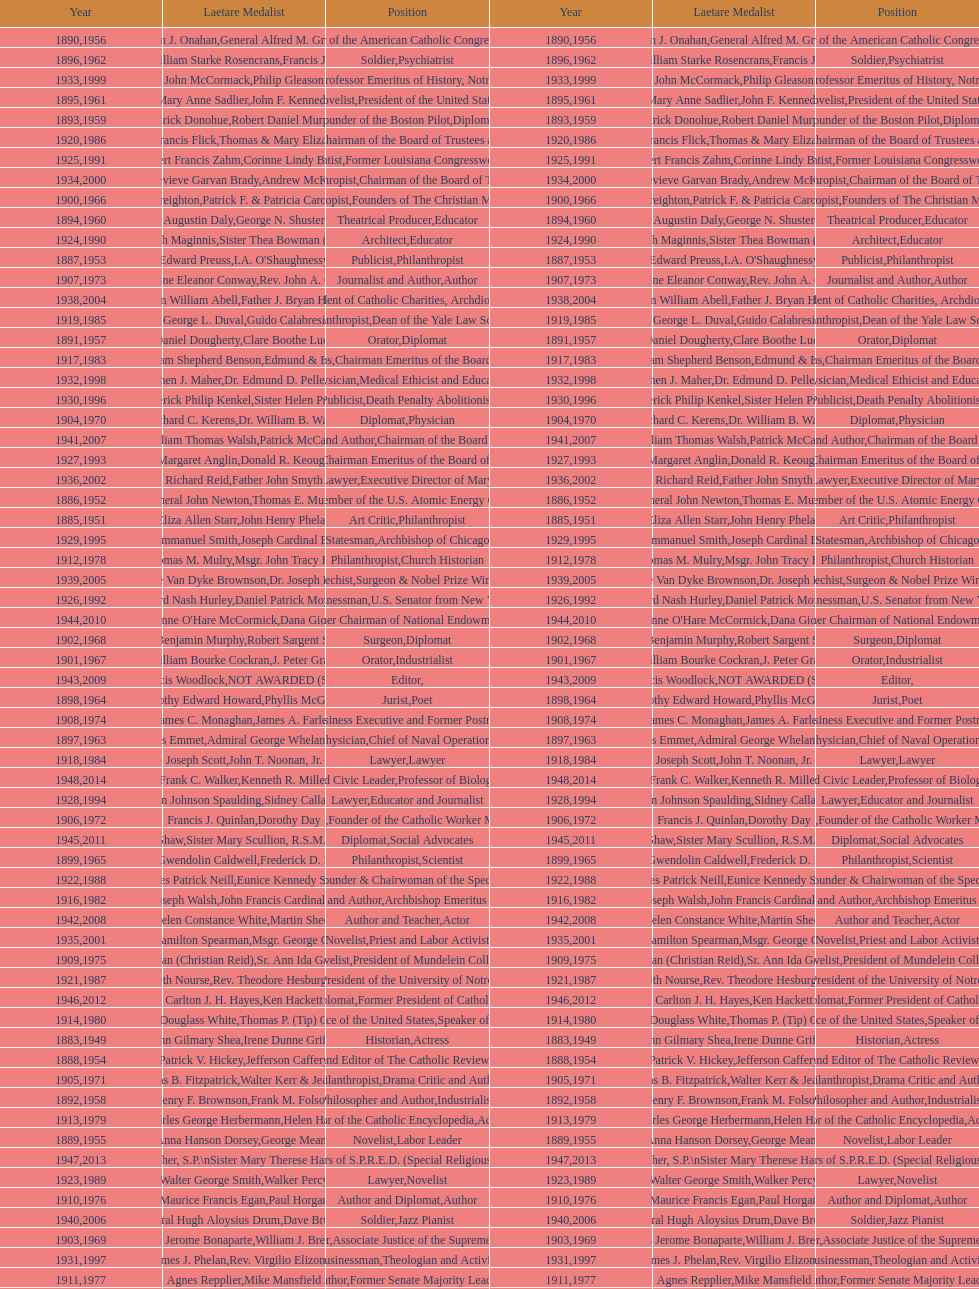What are the total number of times soldier is listed as the position on this chart? 4. Give me the full table as a dictionary. {'header': ['Year', 'Laetare Medalist', 'Position', 'Year', 'Laetare Medalist', 'Position'], 'rows': [['1890', 'William J. Onahan', 'Organizer of the American Catholic Congress', '1956', 'General Alfred M. Gruenther', 'Soldier'], ['1896', 'General William Starke Rosencrans', 'Soldier', '1962', 'Francis J. Braceland', 'Psychiatrist'], ['1933', 'John McCormack', 'Artist', '1999', 'Philip Gleason', 'Professor Emeritus of History, Notre Dame'], ['1895', 'Mary Anne Sadlier', 'Novelist', '1961', 'John F. Kennedy', 'President of the United States'], ['1893', 'Patrick Donohue', 'Founder of the Boston Pilot', '1959', 'Robert Daniel Murphy', 'Diplomat'], ['1920', 'Lawrence Francis Flick', 'Physician', '1986', 'Thomas & Mary Elizabeth Carney', 'Chairman of the Board of Trustees and his wife'], ['1925', 'Albert Francis Zahm', 'Scientist', '1991', 'Corinne Lindy Boggs', 'Former Louisiana Congresswoman'], ['1934', 'Genevieve Garvan Brady', 'Philanthropist', '2000', 'Andrew McKenna', 'Chairman of the Board of Trustees'], ['1900', 'John A. Creighton', 'Philanthropist', '1966', 'Patrick F. & Patricia Caron Crowley', 'Founders of The Christian Movement'], ['1894', 'Augustin Daly', 'Theatrical Producer', '1960', 'George N. Shuster', 'Educator'], ['1924', 'Charles Donagh Maginnis', 'Architect', '1990', 'Sister Thea Bowman (posthumously)', 'Educator'], ['1887', 'Edward Preuss', 'Publicist', '1953', "I.A. O'Shaughnessy", 'Philanthropist'], ['1907', 'Katherine Eleanor Conway', 'Journalist and Author', '1973', "Rev. John A. O'Brien", 'Author'], ['1938', 'Irvin William Abell', 'Surgeon', '2004', 'Father J. Bryan Hehir', 'President of Catholic Charities, Archdiocese of Boston'], ['1919', 'George L. Duval', 'Philanthropist', '1985', 'Guido Calabresi', 'Dean of the Yale Law School'], ['1891', 'Daniel Dougherty', 'Orator', '1957', 'Clare Boothe Luce', 'Diplomat'], ['1917', 'Admiral William Shepherd Benson', 'Chief of Naval Operations', '1983', 'Edmund & Evelyn Stephan', 'Chairman Emeritus of the Board of Trustees and his wife'], ['1932', 'Stephen J. Maher', 'Physician', '1998', 'Dr. Edmund D. Pellegrino', 'Medical Ethicist and Educator'], ['1930', 'Frederick Philip Kenkel', 'Publicist', '1996', 'Sister Helen Prejean', 'Death Penalty Abolitionist'], ['1904', 'Richard C. Kerens', 'Diplomat', '1970', 'Dr. William B. Walsh', 'Physician'], ['1941', 'William Thomas Walsh', 'Journalist and Author', '2007', 'Patrick McCartan', 'Chairman of the Board of Trustees'], ['1927', 'Margaret Anglin', 'Actress', '1993', 'Donald R. Keough', 'Chairman Emeritus of the Board of Trustees'], ['1936', 'Richard Reid', 'Journalist and Lawyer', '2002', 'Father John Smyth', 'Executive Director of Maryville Academy'], ['1886', 'General John Newton', 'Engineer', '1952', 'Thomas E. Murray', 'Member of the U.S. Atomic Energy Commission'], ['1885', 'Eliza Allen Starr', 'Art Critic', '1951', 'John Henry Phelan', 'Philanthropist'], ['1929', 'Alfred Emmanuel Smith', 'Statesman', '1995', 'Joseph Cardinal Bernardin', 'Archbishop of Chicago'], ['1912', 'Thomas M. Mulry', 'Philanthropist', '1978', 'Msgr. John Tracy Ellis', 'Church Historian'], ['1939', 'Josephine Van Dyke Brownson', 'Catechist', '2005', 'Dr. Joseph E. Murray', 'Surgeon & Nobel Prize Winner'], ['1926', 'Edward Nash Hurley', 'Businessman', '1992', 'Daniel Patrick Moynihan', 'U.S. Senator from New York'], ['1944', "Anne O'Hare McCormick", 'Journalist', '2010', 'Dana Gioia', 'Former Chairman of National Endowment for the Arts'], ['1902', 'John Benjamin Murphy', 'Surgeon', '1968', 'Robert Sargent Shriver', 'Diplomat'], ['1901', 'William Bourke Cockran', 'Orator', '1967', 'J. Peter Grace', 'Industrialist'], ['1943', 'Thomas Francis Woodlock', 'Editor', '2009', 'NOT AWARDED (SEE BELOW)', ''], ['1898', 'Timothy Edward Howard', 'Jurist', '1964', 'Phyllis McGinley', 'Poet'], ['1908', 'James C. Monaghan', 'Economist', '1974', 'James A. Farley', 'Business Executive and Former Postmaster General'], ['1897', 'Thomas Addis Emmet', 'Physician', '1963', 'Admiral George Whelan Anderson, Jr.', 'Chief of Naval Operations'], ['1918', 'Joseph Scott', 'Lawyer', '1984', 'John T. Noonan, Jr.', 'Lawyer'], ['1948', 'Frank C. Walker', 'Postmaster General and Civic Leader', '2014', 'Kenneth R. Miller', 'Professor of Biology at Brown University'], ['1928', 'John Johnson Spaulding', 'Lawyer', '1994', 'Sidney Callahan', 'Educator and Journalist'], ['1906', 'Francis J. Quinlan', 'Physician', '1972', 'Dorothy Day', 'Founder of the Catholic Worker Movement'], ['1945', 'Gardiner Howland Shaw', 'Diplomat', '2011', 'Sister Mary Scullion, R.S.M., & Joan McConnon', 'Social Advocates'], ['1899', 'Mary Gwendolin Caldwell', 'Philanthropist', '1965', 'Frederick D. Rossini', 'Scientist'], ['1922', 'Charles Patrick Neill', 'Economist', '1988', 'Eunice Kennedy Shriver', 'Founder & Chairwoman of the Special Olympics'], ['1916', 'James Joseph Walsh', 'Physician and Author', '1982', 'John Francis Cardinal Dearden', 'Archbishop Emeritus of Detroit'], ['1942', 'Helen Constance White', 'Author and Teacher', '2008', 'Martin Sheen', 'Actor'], ['1935', 'Francis Hamilton Spearman', 'Novelist', '2001', 'Msgr. George G. Higgins', 'Priest and Labor Activist'], ['1909', 'Frances Tieran (Christian Reid)', 'Novelist', '1975', 'Sr. Ann Ida Gannon, BMV', 'President of Mundelein College'], ['1921', 'Elizabeth Nourse', 'Artist', '1987', 'Rev. Theodore Hesburgh, CSC', 'President of the University of Notre Dame'], ['1946', 'Carlton J. H. Hayes', 'Historian and Diplomat', '2012', 'Ken Hackett', 'Former President of Catholic Relief Services'], ['1914', 'Edward Douglass White', 'Chief Justice of the United States', '1980', "Thomas P. (Tip) O'Neill Jr.", 'Speaker of the House'], ['1883', 'John Gilmary Shea', 'Historian', '1949', 'Irene Dunne Griffin', 'Actress'], ['1888', 'Patrick V. Hickey', 'Founder and Editor of The Catholic Review', '1954', 'Jefferson Caffery', 'Diplomat'], ['1905', 'Thomas B. Fitzpatrick', 'Philanthropist', '1971', 'Walter Kerr & Jean Kerr', 'Drama Critic and Author'], ['1892', 'Henry F. Brownson', 'Philosopher and Author', '1958', 'Frank M. Folsom', 'Industrialist'], ['1913', 'Charles George Herbermann', 'Editor of the Catholic Encyclopedia', '1979', 'Helen Hayes', 'Actress'], ['1889', 'Anna Hanson Dorsey', 'Novelist', '1955', 'George Meany', 'Labor Leader'], ['1947', 'William G. Bruce', 'Publisher and Civic Leader', '2013', 'Sister Susanne Gallagher, S.P.\\nSister Mary Therese Harrington, S.H.\\nRev. James H. McCarthy', 'Founders of S.P.R.E.D. (Special Religious Education Development Network)'], ['1923', 'Walter George Smith', 'Lawyer', '1989', 'Walker Percy', 'Novelist'], ['1910', 'Maurice Francis Egan', 'Author and Diplomat', '1976', 'Paul Horgan', 'Author'], ['1940', 'General Hugh Aloysius Drum', 'Soldier', '2006', 'Dave Brubeck', 'Jazz Pianist'], ['1903', 'Charles Jerome Bonaparte', 'Lawyer', '1969', 'William J. Brennan Jr.', 'Associate Justice of the Supreme Court'], ['1931', 'James J. Phelan', 'Businessman', '1997', 'Rev. Virgilio Elizondo', 'Theologian and Activist'], ['1911', 'Agnes Repplier', 'Author', '1977', 'Mike Mansfield', 'Former Senate Majority Leader'], ['1884', 'Patrick Charles Keely', 'Architect', '1950', 'General Joseph L. Collins', 'Soldier'], ['1915', 'Mary V. Merrick', 'Philanthropist', '1981', 'Edmund Sixtus Muskie', 'Secretary of State'], ['1937', 'Jeremiah D. M. Ford', 'Scholar', '2003', "Peter and Margaret O'Brien Steinfels", 'Editors of Commonweal']]} 